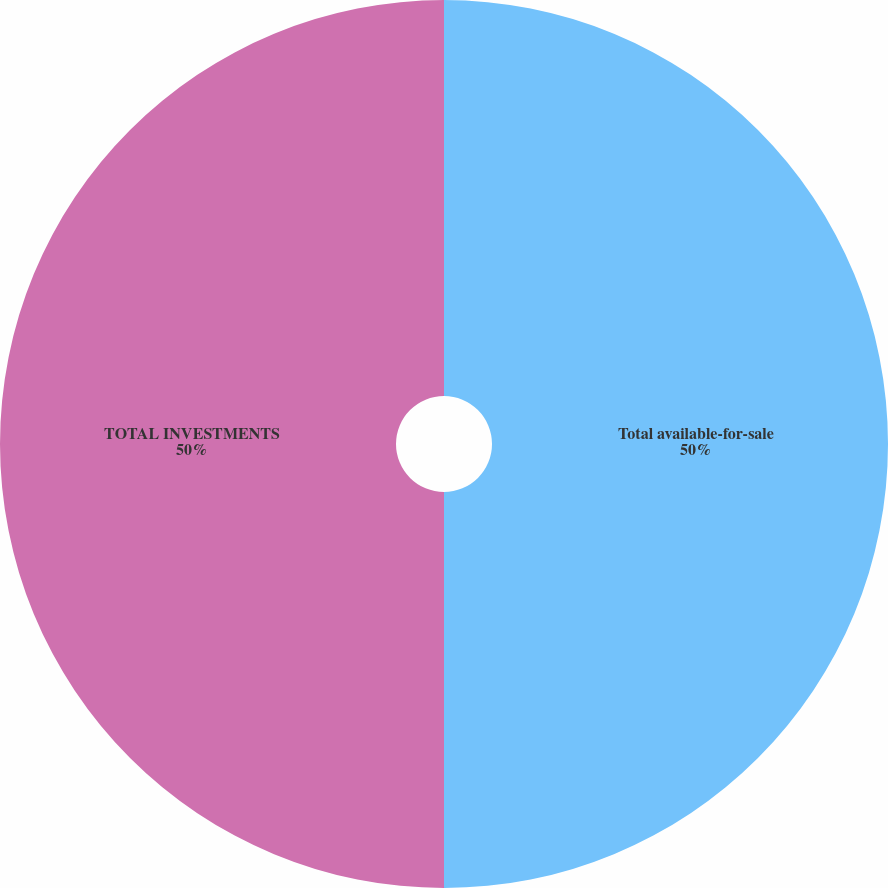<chart> <loc_0><loc_0><loc_500><loc_500><pie_chart><fcel>Total available-for-sale<fcel>TOTAL INVESTMENTS<nl><fcel>50.0%<fcel>50.0%<nl></chart> 